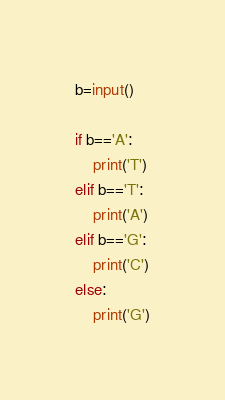<code> <loc_0><loc_0><loc_500><loc_500><_Python_>b=input()
 
if b=='A':
    print('T')
elif b=='T':
    print('A')
elif b=='G':
    print('C')
else:
    print('G')</code> 